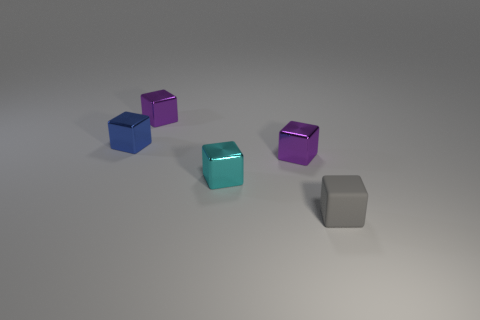Subtract all cyan cylinders. How many purple blocks are left? 2 Subtract all tiny shiny cubes. How many cubes are left? 1 Subtract 2 cubes. How many cubes are left? 3 Subtract all cyan blocks. How many blocks are left? 4 Add 2 big red spheres. How many objects exist? 7 Subtract all yellow blocks. Subtract all red cylinders. How many blocks are left? 5 Subtract all small gray cubes. Subtract all purple things. How many objects are left? 2 Add 3 tiny cyan blocks. How many tiny cyan blocks are left? 4 Add 4 cubes. How many cubes exist? 9 Subtract 1 blue cubes. How many objects are left? 4 